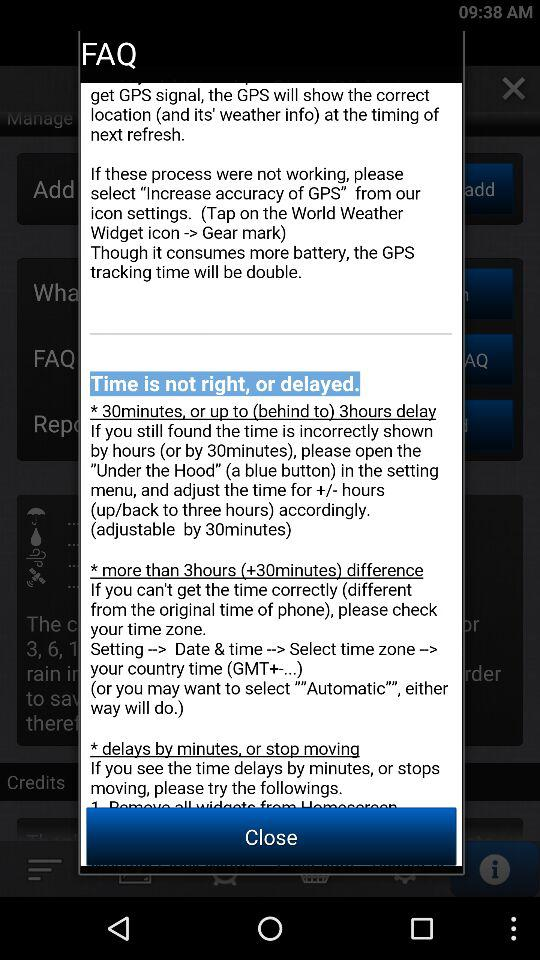How to set time zone settings?
When the provided information is insufficient, respond with <no answer>. <no answer> 